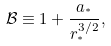<formula> <loc_0><loc_0><loc_500><loc_500>\mathcal { B } \equiv 1 + \frac { a _ { ^ { * } } } { r _ { ^ { * } } ^ { 3 / 2 } } ,</formula> 